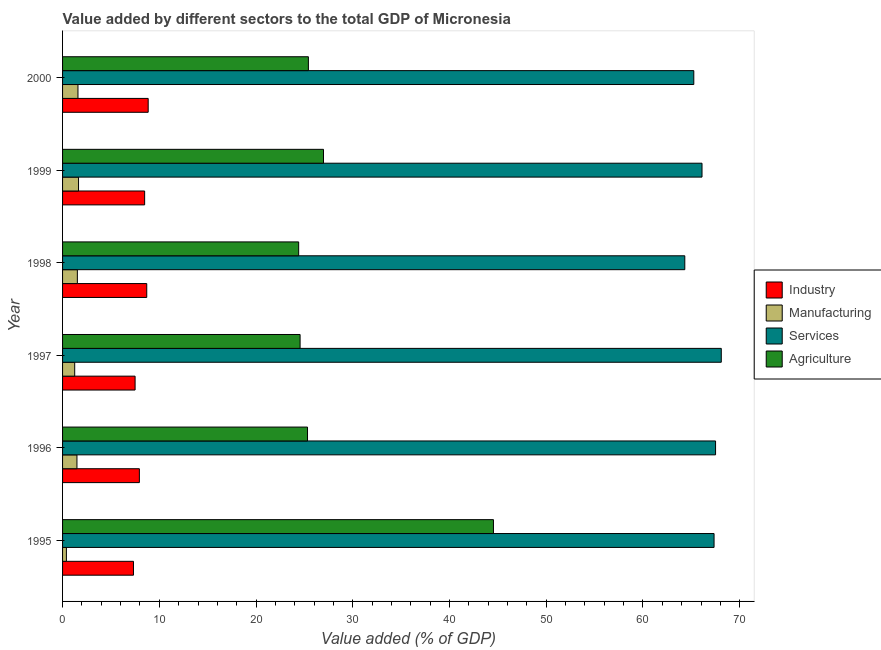How many bars are there on the 1st tick from the top?
Your answer should be compact. 4. How many bars are there on the 6th tick from the bottom?
Keep it short and to the point. 4. What is the value added by manufacturing sector in 1995?
Provide a succinct answer. 0.4. Across all years, what is the maximum value added by agricultural sector?
Make the answer very short. 44.54. Across all years, what is the minimum value added by manufacturing sector?
Your answer should be compact. 0.4. What is the total value added by industrial sector in the graph?
Your response must be concise. 48.81. What is the difference between the value added by agricultural sector in 1996 and that in 1999?
Offer a terse response. -1.65. What is the difference between the value added by agricultural sector in 1997 and the value added by manufacturing sector in 1998?
Provide a succinct answer. 23.03. What is the average value added by services sector per year?
Provide a succinct answer. 66.44. In the year 1998, what is the difference between the value added by industrial sector and value added by manufacturing sector?
Keep it short and to the point. 7.17. In how many years, is the value added by services sector greater than 8 %?
Your answer should be compact. 6. What is the ratio of the value added by services sector in 1995 to that in 1997?
Your answer should be very brief. 0.99. What is the difference between the highest and the second highest value added by manufacturing sector?
Your answer should be very brief. 0.06. What is the difference between the highest and the lowest value added by services sector?
Provide a short and direct response. 3.77. Is the sum of the value added by industrial sector in 1996 and 1999 greater than the maximum value added by agricultural sector across all years?
Provide a short and direct response. No. What does the 4th bar from the top in 1995 represents?
Provide a succinct answer. Industry. What does the 4th bar from the bottom in 1999 represents?
Offer a very short reply. Agriculture. Is it the case that in every year, the sum of the value added by industrial sector and value added by manufacturing sector is greater than the value added by services sector?
Keep it short and to the point. No. How many years are there in the graph?
Your answer should be very brief. 6. Does the graph contain any zero values?
Give a very brief answer. No. Does the graph contain grids?
Make the answer very short. No. How are the legend labels stacked?
Your answer should be compact. Vertical. What is the title of the graph?
Ensure brevity in your answer.  Value added by different sectors to the total GDP of Micronesia. What is the label or title of the X-axis?
Make the answer very short. Value added (% of GDP). What is the Value added (% of GDP) in Industry in 1995?
Your answer should be very brief. 7.33. What is the Value added (% of GDP) of Manufacturing in 1995?
Keep it short and to the point. 0.4. What is the Value added (% of GDP) in Services in 1995?
Your answer should be very brief. 67.35. What is the Value added (% of GDP) of Agriculture in 1995?
Give a very brief answer. 44.54. What is the Value added (% of GDP) in Industry in 1996?
Offer a very short reply. 7.94. What is the Value added (% of GDP) in Manufacturing in 1996?
Your response must be concise. 1.49. What is the Value added (% of GDP) of Services in 1996?
Ensure brevity in your answer.  67.5. What is the Value added (% of GDP) of Agriculture in 1996?
Provide a short and direct response. 25.32. What is the Value added (% of GDP) in Industry in 1997?
Keep it short and to the point. 7.5. What is the Value added (% of GDP) of Manufacturing in 1997?
Your response must be concise. 1.25. What is the Value added (% of GDP) in Services in 1997?
Make the answer very short. 68.09. What is the Value added (% of GDP) in Agriculture in 1997?
Offer a terse response. 24.56. What is the Value added (% of GDP) in Industry in 1998?
Offer a terse response. 8.7. What is the Value added (% of GDP) in Manufacturing in 1998?
Make the answer very short. 1.53. What is the Value added (% of GDP) in Services in 1998?
Keep it short and to the point. 64.32. What is the Value added (% of GDP) in Agriculture in 1998?
Your answer should be very brief. 24.41. What is the Value added (% of GDP) of Industry in 1999?
Your answer should be compact. 8.48. What is the Value added (% of GDP) in Manufacturing in 1999?
Provide a short and direct response. 1.65. What is the Value added (% of GDP) of Services in 1999?
Give a very brief answer. 66.1. What is the Value added (% of GDP) of Agriculture in 1999?
Make the answer very short. 26.97. What is the Value added (% of GDP) of Industry in 2000?
Offer a very short reply. 8.85. What is the Value added (% of GDP) of Manufacturing in 2000?
Ensure brevity in your answer.  1.59. What is the Value added (% of GDP) in Services in 2000?
Your answer should be very brief. 65.25. What is the Value added (% of GDP) of Agriculture in 2000?
Provide a short and direct response. 25.41. Across all years, what is the maximum Value added (% of GDP) in Industry?
Your answer should be compact. 8.85. Across all years, what is the maximum Value added (% of GDP) of Manufacturing?
Keep it short and to the point. 1.65. Across all years, what is the maximum Value added (% of GDP) of Services?
Offer a very short reply. 68.09. Across all years, what is the maximum Value added (% of GDP) of Agriculture?
Your answer should be compact. 44.54. Across all years, what is the minimum Value added (% of GDP) in Industry?
Your answer should be very brief. 7.33. Across all years, what is the minimum Value added (% of GDP) in Manufacturing?
Provide a succinct answer. 0.4. Across all years, what is the minimum Value added (% of GDP) of Services?
Your answer should be very brief. 64.32. Across all years, what is the minimum Value added (% of GDP) in Agriculture?
Your answer should be very brief. 24.41. What is the total Value added (% of GDP) of Industry in the graph?
Provide a succinct answer. 48.81. What is the total Value added (% of GDP) in Manufacturing in the graph?
Your response must be concise. 7.91. What is the total Value added (% of GDP) of Services in the graph?
Provide a succinct answer. 398.63. What is the total Value added (% of GDP) in Agriculture in the graph?
Ensure brevity in your answer.  171.21. What is the difference between the Value added (% of GDP) of Industry in 1995 and that in 1996?
Your answer should be very brief. -0.61. What is the difference between the Value added (% of GDP) of Manufacturing in 1995 and that in 1996?
Offer a terse response. -1.09. What is the difference between the Value added (% of GDP) of Services in 1995 and that in 1996?
Provide a short and direct response. -0.16. What is the difference between the Value added (% of GDP) of Agriculture in 1995 and that in 1996?
Your response must be concise. 19.22. What is the difference between the Value added (% of GDP) of Industry in 1995 and that in 1997?
Provide a short and direct response. -0.17. What is the difference between the Value added (% of GDP) of Manufacturing in 1995 and that in 1997?
Give a very brief answer. -0.86. What is the difference between the Value added (% of GDP) of Services in 1995 and that in 1997?
Give a very brief answer. -0.75. What is the difference between the Value added (% of GDP) in Agriculture in 1995 and that in 1997?
Make the answer very short. 19.99. What is the difference between the Value added (% of GDP) of Industry in 1995 and that in 1998?
Provide a short and direct response. -1.37. What is the difference between the Value added (% of GDP) in Manufacturing in 1995 and that in 1998?
Your response must be concise. -1.13. What is the difference between the Value added (% of GDP) of Services in 1995 and that in 1998?
Offer a very short reply. 3.02. What is the difference between the Value added (% of GDP) in Agriculture in 1995 and that in 1998?
Ensure brevity in your answer.  20.14. What is the difference between the Value added (% of GDP) in Industry in 1995 and that in 1999?
Give a very brief answer. -1.15. What is the difference between the Value added (% of GDP) of Manufacturing in 1995 and that in 1999?
Give a very brief answer. -1.25. What is the difference between the Value added (% of GDP) of Services in 1995 and that in 1999?
Ensure brevity in your answer.  1.24. What is the difference between the Value added (% of GDP) in Agriculture in 1995 and that in 1999?
Give a very brief answer. 17.57. What is the difference between the Value added (% of GDP) in Industry in 1995 and that in 2000?
Offer a very short reply. -1.52. What is the difference between the Value added (% of GDP) of Manufacturing in 1995 and that in 2000?
Ensure brevity in your answer.  -1.19. What is the difference between the Value added (% of GDP) of Services in 1995 and that in 2000?
Your answer should be compact. 2.09. What is the difference between the Value added (% of GDP) of Agriculture in 1995 and that in 2000?
Provide a short and direct response. 19.13. What is the difference between the Value added (% of GDP) in Industry in 1996 and that in 1997?
Offer a very short reply. 0.44. What is the difference between the Value added (% of GDP) in Manufacturing in 1996 and that in 1997?
Make the answer very short. 0.23. What is the difference between the Value added (% of GDP) of Services in 1996 and that in 1997?
Give a very brief answer. -0.59. What is the difference between the Value added (% of GDP) of Agriculture in 1996 and that in 1997?
Give a very brief answer. 0.77. What is the difference between the Value added (% of GDP) in Industry in 1996 and that in 1998?
Provide a succinct answer. -0.76. What is the difference between the Value added (% of GDP) of Manufacturing in 1996 and that in 1998?
Your answer should be very brief. -0.04. What is the difference between the Value added (% of GDP) in Services in 1996 and that in 1998?
Offer a terse response. 3.18. What is the difference between the Value added (% of GDP) of Agriculture in 1996 and that in 1998?
Provide a succinct answer. 0.91. What is the difference between the Value added (% of GDP) in Industry in 1996 and that in 1999?
Your answer should be very brief. -0.54. What is the difference between the Value added (% of GDP) in Manufacturing in 1996 and that in 1999?
Ensure brevity in your answer.  -0.16. What is the difference between the Value added (% of GDP) of Services in 1996 and that in 1999?
Provide a succinct answer. 1.4. What is the difference between the Value added (% of GDP) in Agriculture in 1996 and that in 1999?
Provide a short and direct response. -1.65. What is the difference between the Value added (% of GDP) of Industry in 1996 and that in 2000?
Your answer should be compact. -0.91. What is the difference between the Value added (% of GDP) of Manufacturing in 1996 and that in 2000?
Offer a very short reply. -0.1. What is the difference between the Value added (% of GDP) of Services in 1996 and that in 2000?
Keep it short and to the point. 2.25. What is the difference between the Value added (% of GDP) of Agriculture in 1996 and that in 2000?
Your answer should be very brief. -0.09. What is the difference between the Value added (% of GDP) in Industry in 1997 and that in 1998?
Your answer should be very brief. -1.21. What is the difference between the Value added (% of GDP) of Manufacturing in 1997 and that in 1998?
Provide a succinct answer. -0.28. What is the difference between the Value added (% of GDP) of Services in 1997 and that in 1998?
Provide a succinct answer. 3.77. What is the difference between the Value added (% of GDP) of Agriculture in 1997 and that in 1998?
Give a very brief answer. 0.15. What is the difference between the Value added (% of GDP) in Industry in 1997 and that in 1999?
Offer a very short reply. -0.99. What is the difference between the Value added (% of GDP) of Manufacturing in 1997 and that in 1999?
Your answer should be compact. -0.4. What is the difference between the Value added (% of GDP) of Services in 1997 and that in 1999?
Ensure brevity in your answer.  1.99. What is the difference between the Value added (% of GDP) in Agriculture in 1997 and that in 1999?
Offer a very short reply. -2.42. What is the difference between the Value added (% of GDP) of Industry in 1997 and that in 2000?
Ensure brevity in your answer.  -1.35. What is the difference between the Value added (% of GDP) of Manufacturing in 1997 and that in 2000?
Offer a very short reply. -0.34. What is the difference between the Value added (% of GDP) in Services in 1997 and that in 2000?
Your answer should be compact. 2.84. What is the difference between the Value added (% of GDP) of Agriculture in 1997 and that in 2000?
Your answer should be very brief. -0.86. What is the difference between the Value added (% of GDP) in Industry in 1998 and that in 1999?
Offer a very short reply. 0.22. What is the difference between the Value added (% of GDP) in Manufacturing in 1998 and that in 1999?
Offer a very short reply. -0.12. What is the difference between the Value added (% of GDP) in Services in 1998 and that in 1999?
Provide a short and direct response. -1.78. What is the difference between the Value added (% of GDP) of Agriculture in 1998 and that in 1999?
Provide a succinct answer. -2.57. What is the difference between the Value added (% of GDP) of Industry in 1998 and that in 2000?
Offer a very short reply. -0.15. What is the difference between the Value added (% of GDP) in Manufacturing in 1998 and that in 2000?
Keep it short and to the point. -0.06. What is the difference between the Value added (% of GDP) of Services in 1998 and that in 2000?
Give a very brief answer. -0.93. What is the difference between the Value added (% of GDP) in Agriculture in 1998 and that in 2000?
Make the answer very short. -1. What is the difference between the Value added (% of GDP) in Industry in 1999 and that in 2000?
Your answer should be compact. -0.37. What is the difference between the Value added (% of GDP) of Manufacturing in 1999 and that in 2000?
Make the answer very short. 0.06. What is the difference between the Value added (% of GDP) in Services in 1999 and that in 2000?
Provide a succinct answer. 0.85. What is the difference between the Value added (% of GDP) of Agriculture in 1999 and that in 2000?
Make the answer very short. 1.56. What is the difference between the Value added (% of GDP) of Industry in 1995 and the Value added (% of GDP) of Manufacturing in 1996?
Offer a terse response. 5.84. What is the difference between the Value added (% of GDP) of Industry in 1995 and the Value added (% of GDP) of Services in 1996?
Offer a terse response. -60.17. What is the difference between the Value added (% of GDP) in Industry in 1995 and the Value added (% of GDP) in Agriculture in 1996?
Give a very brief answer. -17.99. What is the difference between the Value added (% of GDP) of Manufacturing in 1995 and the Value added (% of GDP) of Services in 1996?
Make the answer very short. -67.11. What is the difference between the Value added (% of GDP) in Manufacturing in 1995 and the Value added (% of GDP) in Agriculture in 1996?
Offer a very short reply. -24.92. What is the difference between the Value added (% of GDP) in Services in 1995 and the Value added (% of GDP) in Agriculture in 1996?
Your answer should be compact. 42.03. What is the difference between the Value added (% of GDP) of Industry in 1995 and the Value added (% of GDP) of Manufacturing in 1997?
Your answer should be compact. 6.08. What is the difference between the Value added (% of GDP) of Industry in 1995 and the Value added (% of GDP) of Services in 1997?
Make the answer very short. -60.76. What is the difference between the Value added (% of GDP) of Industry in 1995 and the Value added (% of GDP) of Agriculture in 1997?
Give a very brief answer. -17.23. What is the difference between the Value added (% of GDP) in Manufacturing in 1995 and the Value added (% of GDP) in Services in 1997?
Your response must be concise. -67.7. What is the difference between the Value added (% of GDP) of Manufacturing in 1995 and the Value added (% of GDP) of Agriculture in 1997?
Your answer should be very brief. -24.16. What is the difference between the Value added (% of GDP) of Services in 1995 and the Value added (% of GDP) of Agriculture in 1997?
Provide a succinct answer. 42.79. What is the difference between the Value added (% of GDP) of Industry in 1995 and the Value added (% of GDP) of Manufacturing in 1998?
Keep it short and to the point. 5.8. What is the difference between the Value added (% of GDP) of Industry in 1995 and the Value added (% of GDP) of Services in 1998?
Provide a succinct answer. -56.99. What is the difference between the Value added (% of GDP) of Industry in 1995 and the Value added (% of GDP) of Agriculture in 1998?
Provide a succinct answer. -17.08. What is the difference between the Value added (% of GDP) of Manufacturing in 1995 and the Value added (% of GDP) of Services in 1998?
Offer a very short reply. -63.93. What is the difference between the Value added (% of GDP) of Manufacturing in 1995 and the Value added (% of GDP) of Agriculture in 1998?
Provide a succinct answer. -24.01. What is the difference between the Value added (% of GDP) of Services in 1995 and the Value added (% of GDP) of Agriculture in 1998?
Your response must be concise. 42.94. What is the difference between the Value added (% of GDP) in Industry in 1995 and the Value added (% of GDP) in Manufacturing in 1999?
Provide a succinct answer. 5.68. What is the difference between the Value added (% of GDP) in Industry in 1995 and the Value added (% of GDP) in Services in 1999?
Offer a terse response. -58.77. What is the difference between the Value added (% of GDP) in Industry in 1995 and the Value added (% of GDP) in Agriculture in 1999?
Provide a succinct answer. -19.64. What is the difference between the Value added (% of GDP) in Manufacturing in 1995 and the Value added (% of GDP) in Services in 1999?
Offer a very short reply. -65.71. What is the difference between the Value added (% of GDP) of Manufacturing in 1995 and the Value added (% of GDP) of Agriculture in 1999?
Provide a short and direct response. -26.58. What is the difference between the Value added (% of GDP) in Services in 1995 and the Value added (% of GDP) in Agriculture in 1999?
Make the answer very short. 40.38. What is the difference between the Value added (% of GDP) of Industry in 1995 and the Value added (% of GDP) of Manufacturing in 2000?
Give a very brief answer. 5.74. What is the difference between the Value added (% of GDP) of Industry in 1995 and the Value added (% of GDP) of Services in 2000?
Your response must be concise. -57.92. What is the difference between the Value added (% of GDP) in Industry in 1995 and the Value added (% of GDP) in Agriculture in 2000?
Provide a succinct answer. -18.08. What is the difference between the Value added (% of GDP) in Manufacturing in 1995 and the Value added (% of GDP) in Services in 2000?
Offer a terse response. -64.86. What is the difference between the Value added (% of GDP) of Manufacturing in 1995 and the Value added (% of GDP) of Agriculture in 2000?
Give a very brief answer. -25.02. What is the difference between the Value added (% of GDP) of Services in 1995 and the Value added (% of GDP) of Agriculture in 2000?
Offer a terse response. 41.94. What is the difference between the Value added (% of GDP) of Industry in 1996 and the Value added (% of GDP) of Manufacturing in 1997?
Keep it short and to the point. 6.69. What is the difference between the Value added (% of GDP) in Industry in 1996 and the Value added (% of GDP) in Services in 1997?
Ensure brevity in your answer.  -60.15. What is the difference between the Value added (% of GDP) in Industry in 1996 and the Value added (% of GDP) in Agriculture in 1997?
Offer a terse response. -16.61. What is the difference between the Value added (% of GDP) of Manufacturing in 1996 and the Value added (% of GDP) of Services in 1997?
Your answer should be compact. -66.61. What is the difference between the Value added (% of GDP) of Manufacturing in 1996 and the Value added (% of GDP) of Agriculture in 1997?
Make the answer very short. -23.07. What is the difference between the Value added (% of GDP) in Services in 1996 and the Value added (% of GDP) in Agriculture in 1997?
Your answer should be compact. 42.95. What is the difference between the Value added (% of GDP) of Industry in 1996 and the Value added (% of GDP) of Manufacturing in 1998?
Give a very brief answer. 6.41. What is the difference between the Value added (% of GDP) in Industry in 1996 and the Value added (% of GDP) in Services in 1998?
Offer a terse response. -56.38. What is the difference between the Value added (% of GDP) of Industry in 1996 and the Value added (% of GDP) of Agriculture in 1998?
Your answer should be compact. -16.47. What is the difference between the Value added (% of GDP) in Manufacturing in 1996 and the Value added (% of GDP) in Services in 1998?
Offer a very short reply. -62.84. What is the difference between the Value added (% of GDP) of Manufacturing in 1996 and the Value added (% of GDP) of Agriculture in 1998?
Provide a succinct answer. -22.92. What is the difference between the Value added (% of GDP) of Services in 1996 and the Value added (% of GDP) of Agriculture in 1998?
Your response must be concise. 43.1. What is the difference between the Value added (% of GDP) of Industry in 1996 and the Value added (% of GDP) of Manufacturing in 1999?
Your response must be concise. 6.29. What is the difference between the Value added (% of GDP) of Industry in 1996 and the Value added (% of GDP) of Services in 1999?
Offer a terse response. -58.16. What is the difference between the Value added (% of GDP) of Industry in 1996 and the Value added (% of GDP) of Agriculture in 1999?
Provide a succinct answer. -19.03. What is the difference between the Value added (% of GDP) in Manufacturing in 1996 and the Value added (% of GDP) in Services in 1999?
Your answer should be very brief. -64.62. What is the difference between the Value added (% of GDP) in Manufacturing in 1996 and the Value added (% of GDP) in Agriculture in 1999?
Keep it short and to the point. -25.49. What is the difference between the Value added (% of GDP) in Services in 1996 and the Value added (% of GDP) in Agriculture in 1999?
Give a very brief answer. 40.53. What is the difference between the Value added (% of GDP) of Industry in 1996 and the Value added (% of GDP) of Manufacturing in 2000?
Give a very brief answer. 6.35. What is the difference between the Value added (% of GDP) of Industry in 1996 and the Value added (% of GDP) of Services in 2000?
Offer a very short reply. -57.31. What is the difference between the Value added (% of GDP) in Industry in 1996 and the Value added (% of GDP) in Agriculture in 2000?
Provide a succinct answer. -17.47. What is the difference between the Value added (% of GDP) of Manufacturing in 1996 and the Value added (% of GDP) of Services in 2000?
Provide a short and direct response. -63.77. What is the difference between the Value added (% of GDP) of Manufacturing in 1996 and the Value added (% of GDP) of Agriculture in 2000?
Make the answer very short. -23.93. What is the difference between the Value added (% of GDP) in Services in 1996 and the Value added (% of GDP) in Agriculture in 2000?
Keep it short and to the point. 42.09. What is the difference between the Value added (% of GDP) in Industry in 1997 and the Value added (% of GDP) in Manufacturing in 1998?
Keep it short and to the point. 5.97. What is the difference between the Value added (% of GDP) of Industry in 1997 and the Value added (% of GDP) of Services in 1998?
Your answer should be compact. -56.83. What is the difference between the Value added (% of GDP) of Industry in 1997 and the Value added (% of GDP) of Agriculture in 1998?
Your answer should be compact. -16.91. What is the difference between the Value added (% of GDP) in Manufacturing in 1997 and the Value added (% of GDP) in Services in 1998?
Keep it short and to the point. -63.07. What is the difference between the Value added (% of GDP) in Manufacturing in 1997 and the Value added (% of GDP) in Agriculture in 1998?
Ensure brevity in your answer.  -23.15. What is the difference between the Value added (% of GDP) in Services in 1997 and the Value added (% of GDP) in Agriculture in 1998?
Give a very brief answer. 43.69. What is the difference between the Value added (% of GDP) in Industry in 1997 and the Value added (% of GDP) in Manufacturing in 1999?
Your answer should be compact. 5.85. What is the difference between the Value added (% of GDP) in Industry in 1997 and the Value added (% of GDP) in Services in 1999?
Provide a succinct answer. -58.61. What is the difference between the Value added (% of GDP) in Industry in 1997 and the Value added (% of GDP) in Agriculture in 1999?
Make the answer very short. -19.48. What is the difference between the Value added (% of GDP) in Manufacturing in 1997 and the Value added (% of GDP) in Services in 1999?
Make the answer very short. -64.85. What is the difference between the Value added (% of GDP) in Manufacturing in 1997 and the Value added (% of GDP) in Agriculture in 1999?
Your answer should be compact. -25.72. What is the difference between the Value added (% of GDP) in Services in 1997 and the Value added (% of GDP) in Agriculture in 1999?
Your response must be concise. 41.12. What is the difference between the Value added (% of GDP) of Industry in 1997 and the Value added (% of GDP) of Manufacturing in 2000?
Ensure brevity in your answer.  5.91. What is the difference between the Value added (% of GDP) of Industry in 1997 and the Value added (% of GDP) of Services in 2000?
Keep it short and to the point. -57.76. What is the difference between the Value added (% of GDP) in Industry in 1997 and the Value added (% of GDP) in Agriculture in 2000?
Give a very brief answer. -17.91. What is the difference between the Value added (% of GDP) in Manufacturing in 1997 and the Value added (% of GDP) in Services in 2000?
Give a very brief answer. -64. What is the difference between the Value added (% of GDP) in Manufacturing in 1997 and the Value added (% of GDP) in Agriculture in 2000?
Offer a terse response. -24.16. What is the difference between the Value added (% of GDP) in Services in 1997 and the Value added (% of GDP) in Agriculture in 2000?
Your answer should be compact. 42.68. What is the difference between the Value added (% of GDP) of Industry in 1998 and the Value added (% of GDP) of Manufacturing in 1999?
Provide a succinct answer. 7.05. What is the difference between the Value added (% of GDP) in Industry in 1998 and the Value added (% of GDP) in Services in 1999?
Give a very brief answer. -57.4. What is the difference between the Value added (% of GDP) of Industry in 1998 and the Value added (% of GDP) of Agriculture in 1999?
Your response must be concise. -18.27. What is the difference between the Value added (% of GDP) in Manufacturing in 1998 and the Value added (% of GDP) in Services in 1999?
Ensure brevity in your answer.  -64.57. What is the difference between the Value added (% of GDP) of Manufacturing in 1998 and the Value added (% of GDP) of Agriculture in 1999?
Ensure brevity in your answer.  -25.44. What is the difference between the Value added (% of GDP) in Services in 1998 and the Value added (% of GDP) in Agriculture in 1999?
Ensure brevity in your answer.  37.35. What is the difference between the Value added (% of GDP) of Industry in 1998 and the Value added (% of GDP) of Manufacturing in 2000?
Offer a very short reply. 7.11. What is the difference between the Value added (% of GDP) in Industry in 1998 and the Value added (% of GDP) in Services in 2000?
Ensure brevity in your answer.  -56.55. What is the difference between the Value added (% of GDP) of Industry in 1998 and the Value added (% of GDP) of Agriculture in 2000?
Ensure brevity in your answer.  -16.71. What is the difference between the Value added (% of GDP) of Manufacturing in 1998 and the Value added (% of GDP) of Services in 2000?
Your answer should be very brief. -63.73. What is the difference between the Value added (% of GDP) of Manufacturing in 1998 and the Value added (% of GDP) of Agriculture in 2000?
Provide a succinct answer. -23.88. What is the difference between the Value added (% of GDP) of Services in 1998 and the Value added (% of GDP) of Agriculture in 2000?
Your answer should be compact. 38.91. What is the difference between the Value added (% of GDP) of Industry in 1999 and the Value added (% of GDP) of Manufacturing in 2000?
Your answer should be very brief. 6.89. What is the difference between the Value added (% of GDP) of Industry in 1999 and the Value added (% of GDP) of Services in 2000?
Your answer should be very brief. -56.77. What is the difference between the Value added (% of GDP) of Industry in 1999 and the Value added (% of GDP) of Agriculture in 2000?
Your answer should be compact. -16.93. What is the difference between the Value added (% of GDP) of Manufacturing in 1999 and the Value added (% of GDP) of Services in 2000?
Ensure brevity in your answer.  -63.6. What is the difference between the Value added (% of GDP) in Manufacturing in 1999 and the Value added (% of GDP) in Agriculture in 2000?
Your answer should be compact. -23.76. What is the difference between the Value added (% of GDP) of Services in 1999 and the Value added (% of GDP) of Agriculture in 2000?
Ensure brevity in your answer.  40.69. What is the average Value added (% of GDP) in Industry per year?
Give a very brief answer. 8.13. What is the average Value added (% of GDP) of Manufacturing per year?
Make the answer very short. 1.32. What is the average Value added (% of GDP) of Services per year?
Provide a succinct answer. 66.44. What is the average Value added (% of GDP) in Agriculture per year?
Your answer should be very brief. 28.54. In the year 1995, what is the difference between the Value added (% of GDP) of Industry and Value added (% of GDP) of Manufacturing?
Make the answer very short. 6.93. In the year 1995, what is the difference between the Value added (% of GDP) in Industry and Value added (% of GDP) in Services?
Offer a very short reply. -60.02. In the year 1995, what is the difference between the Value added (% of GDP) of Industry and Value added (% of GDP) of Agriculture?
Keep it short and to the point. -37.21. In the year 1995, what is the difference between the Value added (% of GDP) in Manufacturing and Value added (% of GDP) in Services?
Offer a terse response. -66.95. In the year 1995, what is the difference between the Value added (% of GDP) of Manufacturing and Value added (% of GDP) of Agriculture?
Your response must be concise. -44.15. In the year 1995, what is the difference between the Value added (% of GDP) in Services and Value added (% of GDP) in Agriculture?
Offer a very short reply. 22.8. In the year 1996, what is the difference between the Value added (% of GDP) in Industry and Value added (% of GDP) in Manufacturing?
Make the answer very short. 6.45. In the year 1996, what is the difference between the Value added (% of GDP) in Industry and Value added (% of GDP) in Services?
Give a very brief answer. -59.56. In the year 1996, what is the difference between the Value added (% of GDP) of Industry and Value added (% of GDP) of Agriculture?
Make the answer very short. -17.38. In the year 1996, what is the difference between the Value added (% of GDP) in Manufacturing and Value added (% of GDP) in Services?
Provide a short and direct response. -66.02. In the year 1996, what is the difference between the Value added (% of GDP) of Manufacturing and Value added (% of GDP) of Agriculture?
Provide a succinct answer. -23.83. In the year 1996, what is the difference between the Value added (% of GDP) of Services and Value added (% of GDP) of Agriculture?
Provide a succinct answer. 42.18. In the year 1997, what is the difference between the Value added (% of GDP) in Industry and Value added (% of GDP) in Manufacturing?
Ensure brevity in your answer.  6.24. In the year 1997, what is the difference between the Value added (% of GDP) in Industry and Value added (% of GDP) in Services?
Offer a terse response. -60.6. In the year 1997, what is the difference between the Value added (% of GDP) of Industry and Value added (% of GDP) of Agriculture?
Make the answer very short. -17.06. In the year 1997, what is the difference between the Value added (% of GDP) of Manufacturing and Value added (% of GDP) of Services?
Make the answer very short. -66.84. In the year 1997, what is the difference between the Value added (% of GDP) in Manufacturing and Value added (% of GDP) in Agriculture?
Provide a succinct answer. -23.3. In the year 1997, what is the difference between the Value added (% of GDP) in Services and Value added (% of GDP) in Agriculture?
Your response must be concise. 43.54. In the year 1998, what is the difference between the Value added (% of GDP) of Industry and Value added (% of GDP) of Manufacturing?
Provide a short and direct response. 7.17. In the year 1998, what is the difference between the Value added (% of GDP) in Industry and Value added (% of GDP) in Services?
Ensure brevity in your answer.  -55.62. In the year 1998, what is the difference between the Value added (% of GDP) in Industry and Value added (% of GDP) in Agriculture?
Keep it short and to the point. -15.71. In the year 1998, what is the difference between the Value added (% of GDP) of Manufacturing and Value added (% of GDP) of Services?
Offer a terse response. -62.79. In the year 1998, what is the difference between the Value added (% of GDP) in Manufacturing and Value added (% of GDP) in Agriculture?
Make the answer very short. -22.88. In the year 1998, what is the difference between the Value added (% of GDP) in Services and Value added (% of GDP) in Agriculture?
Offer a terse response. 39.92. In the year 1999, what is the difference between the Value added (% of GDP) of Industry and Value added (% of GDP) of Manufacturing?
Your answer should be very brief. 6.83. In the year 1999, what is the difference between the Value added (% of GDP) of Industry and Value added (% of GDP) of Services?
Your answer should be very brief. -57.62. In the year 1999, what is the difference between the Value added (% of GDP) in Industry and Value added (% of GDP) in Agriculture?
Provide a short and direct response. -18.49. In the year 1999, what is the difference between the Value added (% of GDP) of Manufacturing and Value added (% of GDP) of Services?
Give a very brief answer. -64.45. In the year 1999, what is the difference between the Value added (% of GDP) of Manufacturing and Value added (% of GDP) of Agriculture?
Keep it short and to the point. -25.32. In the year 1999, what is the difference between the Value added (% of GDP) of Services and Value added (% of GDP) of Agriculture?
Your answer should be very brief. 39.13. In the year 2000, what is the difference between the Value added (% of GDP) in Industry and Value added (% of GDP) in Manufacturing?
Make the answer very short. 7.26. In the year 2000, what is the difference between the Value added (% of GDP) in Industry and Value added (% of GDP) in Services?
Ensure brevity in your answer.  -56.4. In the year 2000, what is the difference between the Value added (% of GDP) in Industry and Value added (% of GDP) in Agriculture?
Ensure brevity in your answer.  -16.56. In the year 2000, what is the difference between the Value added (% of GDP) of Manufacturing and Value added (% of GDP) of Services?
Offer a very short reply. -63.66. In the year 2000, what is the difference between the Value added (% of GDP) of Manufacturing and Value added (% of GDP) of Agriculture?
Provide a short and direct response. -23.82. In the year 2000, what is the difference between the Value added (% of GDP) of Services and Value added (% of GDP) of Agriculture?
Ensure brevity in your answer.  39.84. What is the ratio of the Value added (% of GDP) in Manufacturing in 1995 to that in 1996?
Your answer should be compact. 0.27. What is the ratio of the Value added (% of GDP) in Services in 1995 to that in 1996?
Your answer should be compact. 1. What is the ratio of the Value added (% of GDP) of Agriculture in 1995 to that in 1996?
Keep it short and to the point. 1.76. What is the ratio of the Value added (% of GDP) of Industry in 1995 to that in 1997?
Provide a succinct answer. 0.98. What is the ratio of the Value added (% of GDP) of Manufacturing in 1995 to that in 1997?
Ensure brevity in your answer.  0.32. What is the ratio of the Value added (% of GDP) of Agriculture in 1995 to that in 1997?
Offer a very short reply. 1.81. What is the ratio of the Value added (% of GDP) of Industry in 1995 to that in 1998?
Your answer should be compact. 0.84. What is the ratio of the Value added (% of GDP) in Manufacturing in 1995 to that in 1998?
Your answer should be very brief. 0.26. What is the ratio of the Value added (% of GDP) in Services in 1995 to that in 1998?
Your answer should be compact. 1.05. What is the ratio of the Value added (% of GDP) of Agriculture in 1995 to that in 1998?
Your response must be concise. 1.82. What is the ratio of the Value added (% of GDP) of Industry in 1995 to that in 1999?
Your response must be concise. 0.86. What is the ratio of the Value added (% of GDP) in Manufacturing in 1995 to that in 1999?
Your response must be concise. 0.24. What is the ratio of the Value added (% of GDP) in Services in 1995 to that in 1999?
Offer a terse response. 1.02. What is the ratio of the Value added (% of GDP) of Agriculture in 1995 to that in 1999?
Your response must be concise. 1.65. What is the ratio of the Value added (% of GDP) in Industry in 1995 to that in 2000?
Your answer should be very brief. 0.83. What is the ratio of the Value added (% of GDP) in Manufacturing in 1995 to that in 2000?
Make the answer very short. 0.25. What is the ratio of the Value added (% of GDP) of Services in 1995 to that in 2000?
Your response must be concise. 1.03. What is the ratio of the Value added (% of GDP) in Agriculture in 1995 to that in 2000?
Your response must be concise. 1.75. What is the ratio of the Value added (% of GDP) of Industry in 1996 to that in 1997?
Your answer should be compact. 1.06. What is the ratio of the Value added (% of GDP) of Manufacturing in 1996 to that in 1997?
Ensure brevity in your answer.  1.19. What is the ratio of the Value added (% of GDP) in Services in 1996 to that in 1997?
Keep it short and to the point. 0.99. What is the ratio of the Value added (% of GDP) of Agriculture in 1996 to that in 1997?
Your answer should be very brief. 1.03. What is the ratio of the Value added (% of GDP) of Industry in 1996 to that in 1998?
Make the answer very short. 0.91. What is the ratio of the Value added (% of GDP) in Manufacturing in 1996 to that in 1998?
Provide a short and direct response. 0.97. What is the ratio of the Value added (% of GDP) of Services in 1996 to that in 1998?
Offer a very short reply. 1.05. What is the ratio of the Value added (% of GDP) in Agriculture in 1996 to that in 1998?
Offer a terse response. 1.04. What is the ratio of the Value added (% of GDP) in Industry in 1996 to that in 1999?
Your answer should be compact. 0.94. What is the ratio of the Value added (% of GDP) of Manufacturing in 1996 to that in 1999?
Keep it short and to the point. 0.9. What is the ratio of the Value added (% of GDP) in Services in 1996 to that in 1999?
Ensure brevity in your answer.  1.02. What is the ratio of the Value added (% of GDP) in Agriculture in 1996 to that in 1999?
Keep it short and to the point. 0.94. What is the ratio of the Value added (% of GDP) in Industry in 1996 to that in 2000?
Provide a short and direct response. 0.9. What is the ratio of the Value added (% of GDP) in Manufacturing in 1996 to that in 2000?
Offer a very short reply. 0.93. What is the ratio of the Value added (% of GDP) of Services in 1996 to that in 2000?
Keep it short and to the point. 1.03. What is the ratio of the Value added (% of GDP) in Agriculture in 1996 to that in 2000?
Keep it short and to the point. 1. What is the ratio of the Value added (% of GDP) in Industry in 1997 to that in 1998?
Provide a succinct answer. 0.86. What is the ratio of the Value added (% of GDP) in Manufacturing in 1997 to that in 1998?
Ensure brevity in your answer.  0.82. What is the ratio of the Value added (% of GDP) in Services in 1997 to that in 1998?
Provide a short and direct response. 1.06. What is the ratio of the Value added (% of GDP) in Agriculture in 1997 to that in 1998?
Offer a terse response. 1.01. What is the ratio of the Value added (% of GDP) in Industry in 1997 to that in 1999?
Offer a terse response. 0.88. What is the ratio of the Value added (% of GDP) in Manufacturing in 1997 to that in 1999?
Keep it short and to the point. 0.76. What is the ratio of the Value added (% of GDP) in Services in 1997 to that in 1999?
Your answer should be very brief. 1.03. What is the ratio of the Value added (% of GDP) of Agriculture in 1997 to that in 1999?
Give a very brief answer. 0.91. What is the ratio of the Value added (% of GDP) of Industry in 1997 to that in 2000?
Your answer should be compact. 0.85. What is the ratio of the Value added (% of GDP) of Manufacturing in 1997 to that in 2000?
Offer a terse response. 0.79. What is the ratio of the Value added (% of GDP) of Services in 1997 to that in 2000?
Your answer should be compact. 1.04. What is the ratio of the Value added (% of GDP) of Agriculture in 1997 to that in 2000?
Provide a succinct answer. 0.97. What is the ratio of the Value added (% of GDP) of Industry in 1998 to that in 1999?
Give a very brief answer. 1.03. What is the ratio of the Value added (% of GDP) in Manufacturing in 1998 to that in 1999?
Offer a very short reply. 0.93. What is the ratio of the Value added (% of GDP) in Services in 1998 to that in 1999?
Provide a succinct answer. 0.97. What is the ratio of the Value added (% of GDP) of Agriculture in 1998 to that in 1999?
Your response must be concise. 0.9. What is the ratio of the Value added (% of GDP) in Industry in 1998 to that in 2000?
Your answer should be very brief. 0.98. What is the ratio of the Value added (% of GDP) of Manufacturing in 1998 to that in 2000?
Provide a short and direct response. 0.96. What is the ratio of the Value added (% of GDP) in Services in 1998 to that in 2000?
Your answer should be very brief. 0.99. What is the ratio of the Value added (% of GDP) of Agriculture in 1998 to that in 2000?
Your answer should be compact. 0.96. What is the ratio of the Value added (% of GDP) in Industry in 1999 to that in 2000?
Your response must be concise. 0.96. What is the ratio of the Value added (% of GDP) in Manufacturing in 1999 to that in 2000?
Provide a short and direct response. 1.04. What is the ratio of the Value added (% of GDP) in Services in 1999 to that in 2000?
Offer a very short reply. 1.01. What is the ratio of the Value added (% of GDP) of Agriculture in 1999 to that in 2000?
Offer a very short reply. 1.06. What is the difference between the highest and the second highest Value added (% of GDP) in Industry?
Keep it short and to the point. 0.15. What is the difference between the highest and the second highest Value added (% of GDP) of Manufacturing?
Provide a short and direct response. 0.06. What is the difference between the highest and the second highest Value added (% of GDP) in Services?
Offer a very short reply. 0.59. What is the difference between the highest and the second highest Value added (% of GDP) in Agriculture?
Provide a succinct answer. 17.57. What is the difference between the highest and the lowest Value added (% of GDP) of Industry?
Ensure brevity in your answer.  1.52. What is the difference between the highest and the lowest Value added (% of GDP) of Manufacturing?
Offer a very short reply. 1.25. What is the difference between the highest and the lowest Value added (% of GDP) in Services?
Ensure brevity in your answer.  3.77. What is the difference between the highest and the lowest Value added (% of GDP) in Agriculture?
Your answer should be compact. 20.14. 